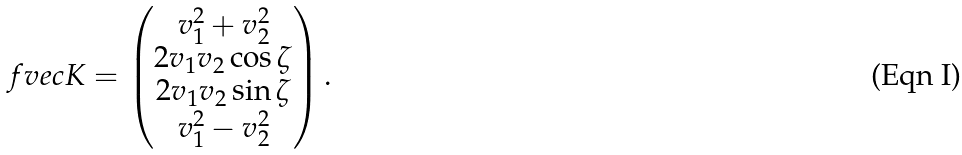<formula> <loc_0><loc_0><loc_500><loc_500>\ f v e c { K } = \begin{pmatrix} v _ { 1 } ^ { 2 } + v _ { 2 } ^ { 2 } \\ 2 v _ { 1 } v _ { 2 } \cos \zeta \\ 2 v _ { 1 } v _ { 2 } \sin \zeta \\ v _ { 1 } ^ { 2 } - v _ { 2 } ^ { 2 } \end{pmatrix} .</formula> 